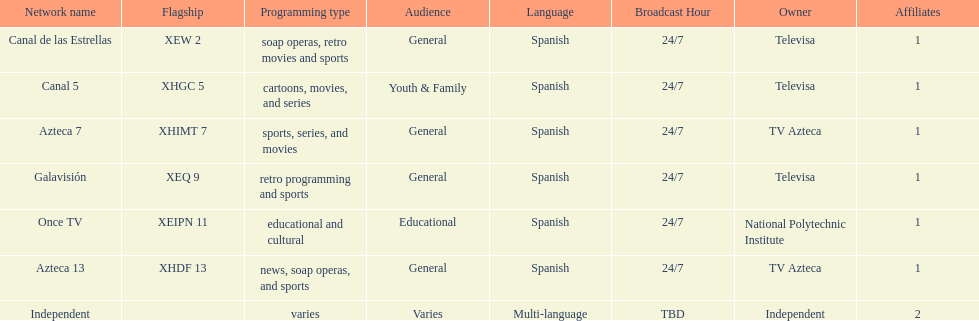Azteca 7 and azteca 13 are both owned by whom? TV Azteca. 